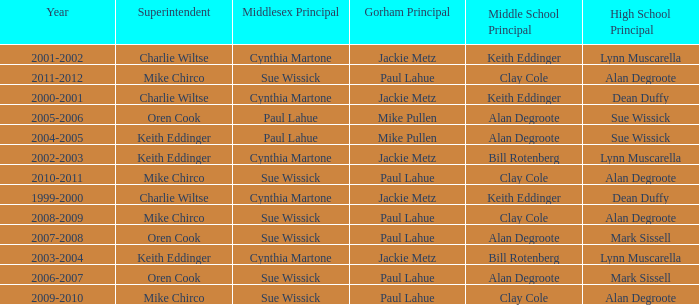Who was the gorham principal in 2010-2011? Paul Lahue. 